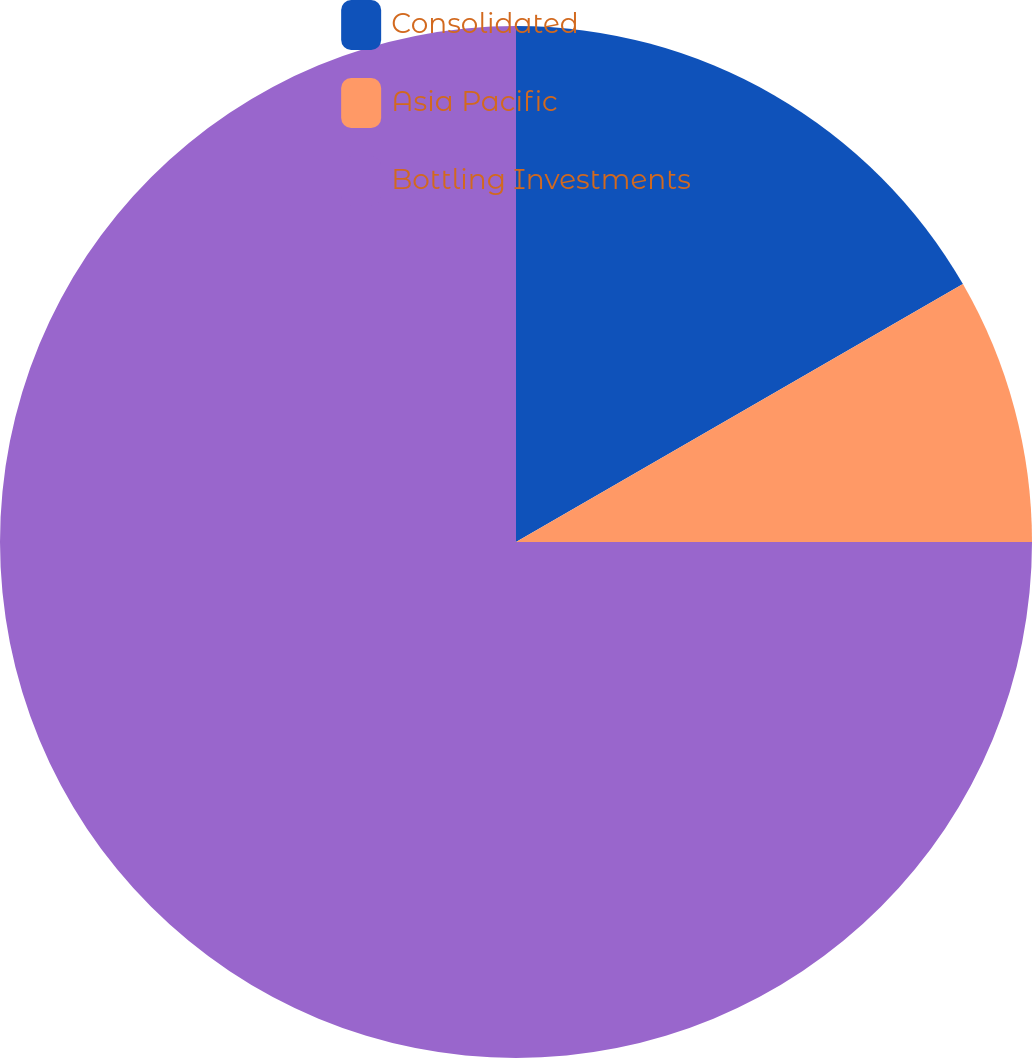<chart> <loc_0><loc_0><loc_500><loc_500><pie_chart><fcel>Consolidated<fcel>Asia Pacific<fcel>Bottling Investments<nl><fcel>16.67%<fcel>8.33%<fcel>75.0%<nl></chart> 